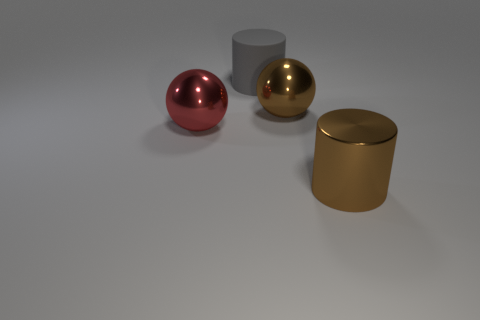What number of other objects are the same color as the large metal cylinder?
Give a very brief answer. 1. Is the color of the big metal cylinder the same as the shiny ball that is behind the red object?
Make the answer very short. Yes. There is a large ball that is right of the large gray rubber cylinder; how many big cylinders are in front of it?
Provide a succinct answer. 1. Are there any other things that are made of the same material as the large red sphere?
Keep it short and to the point. Yes. What material is the big brown thing that is left of the large brown object in front of the shiny sphere that is left of the large gray rubber object made of?
Provide a succinct answer. Metal. There is a big thing that is on the left side of the large brown ball and on the right side of the large red metal thing; what material is it?
Your response must be concise. Rubber. What number of brown metallic things have the same shape as the gray rubber object?
Ensure brevity in your answer.  1. There is a brown metallic object in front of the big sphere to the left of the gray thing; how big is it?
Your response must be concise. Large. Do the large sphere that is right of the big gray matte object and the shiny thing left of the matte thing have the same color?
Ensure brevity in your answer.  No. How many objects are on the right side of the big cylinder behind the sphere to the left of the gray cylinder?
Provide a succinct answer. 2. 